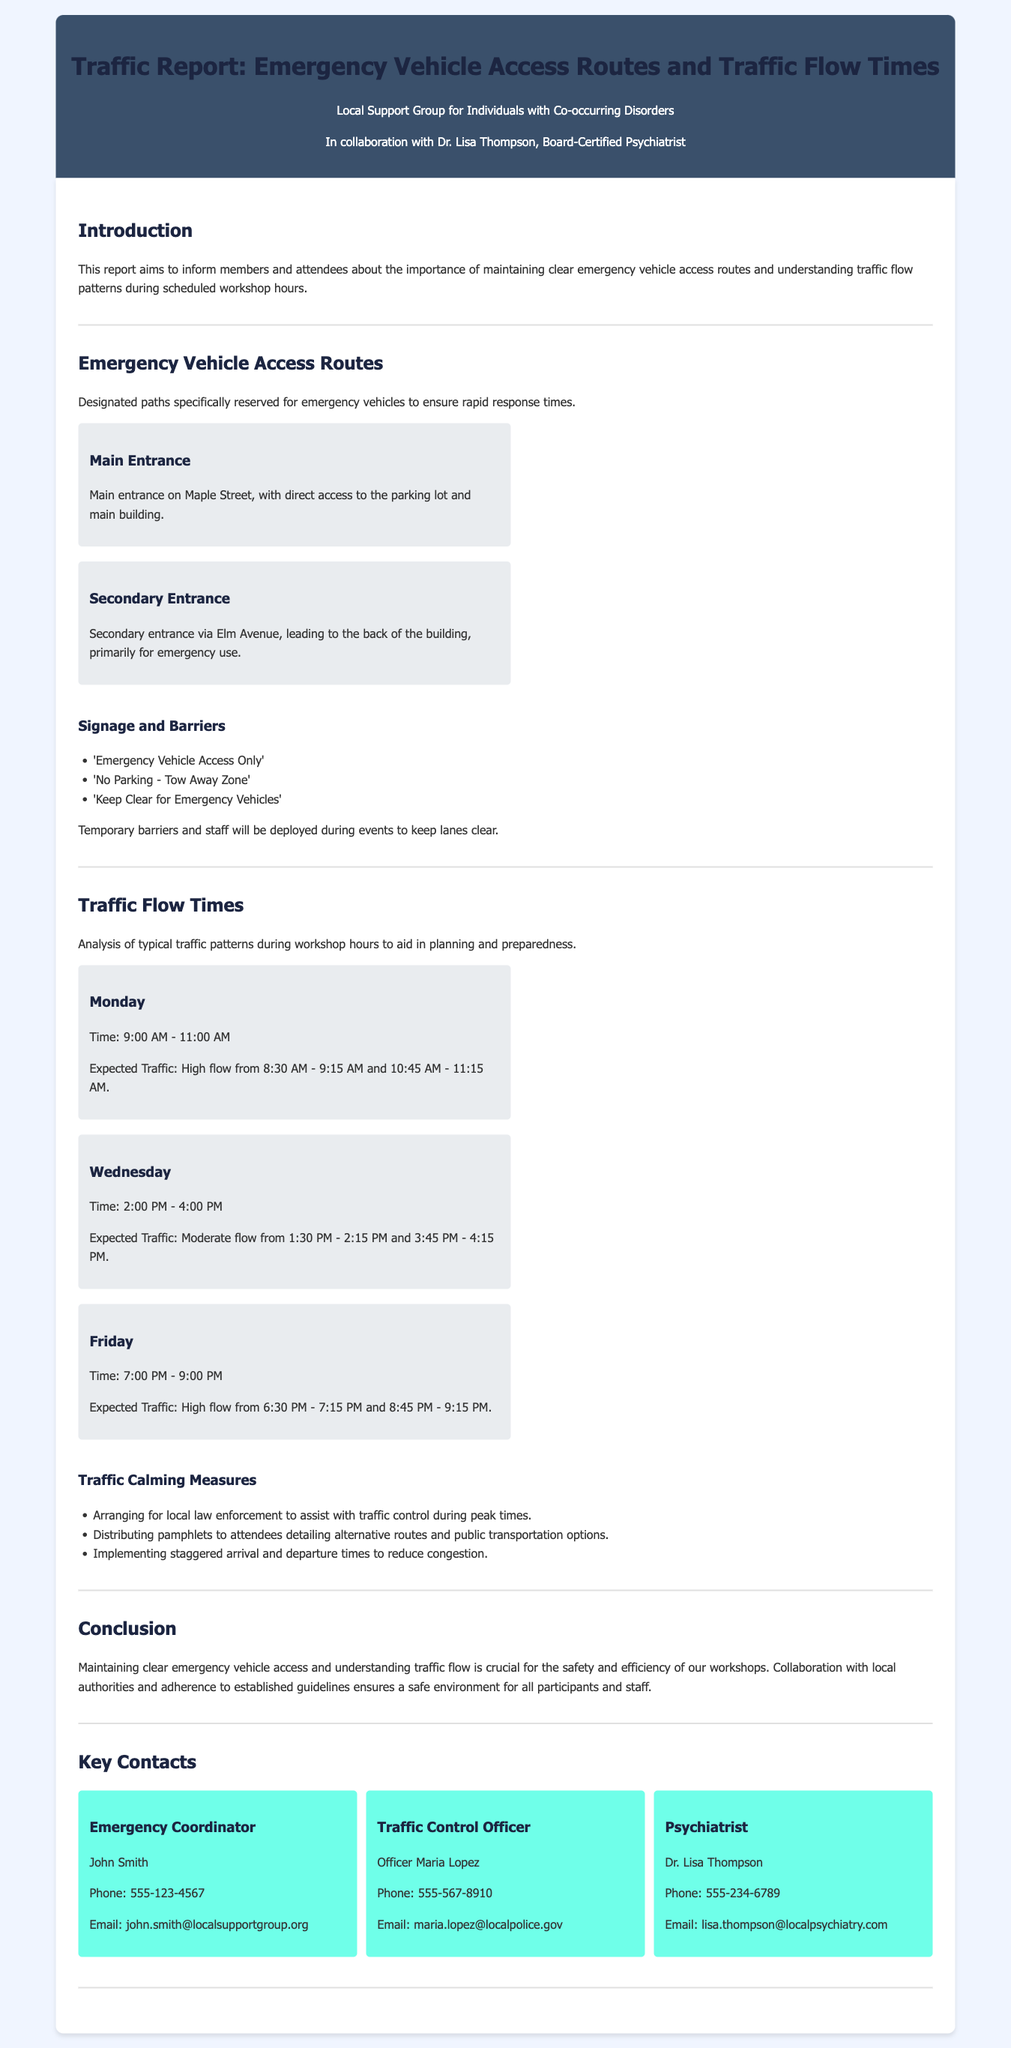What are the designated emergency vehicle access routes? The report specifies two routes: the Main Entrance and the Secondary Entrance, detailing their locations and purposes.
Answer: Main Entrance, Secondary Entrance During which time period is expected traffic high on Mondays? The document states the specific times when high traffic is expected on Mondays, highlighting morning rush hours.
Answer: 8:30 AM - 9:15 AM and 10:45 AM - 11:15 AM Who is the Emergency Coordinator? The report provides the name of the Emergency Coordinator, including their contact information in the key contacts section.
Answer: John Smith What signage is designated for emergency vehicle access? The report provides a list of signs that will be in place to indicate emergency vehicle access restrictions.
Answer: 'Emergency Vehicle Access Only', 'No Parking - Tow Away Zone', 'Keep Clear for Emergency Vehicles' What measures are mentioned to control traffic flow? The document details actions taken to manage traffic during peak workshop hours, emphasizing coordination with local law enforcement.
Answer: Local law enforcement assistance, distributing pamphlets, staggered arrival and departure times What is the expected traffic pattern on Wednesdays? The report outlines typical traffic patterns for Wednesdays, specifying the time frames for expected traffic levels.
Answer: Moderate flow from 1:30 PM - 2:15 PM and 3:45 PM - 4:15 PM What type of report is this document? The document defines itself as a traffic report focused on emergency vehicle access routes and traffic flow times during specific hours.
Answer: Traffic report Who is the Traffic Control Officer? The report includes the name of the individual responsible for traffic control during the workshops, along with contact information.
Answer: Officer Maria Lopez 